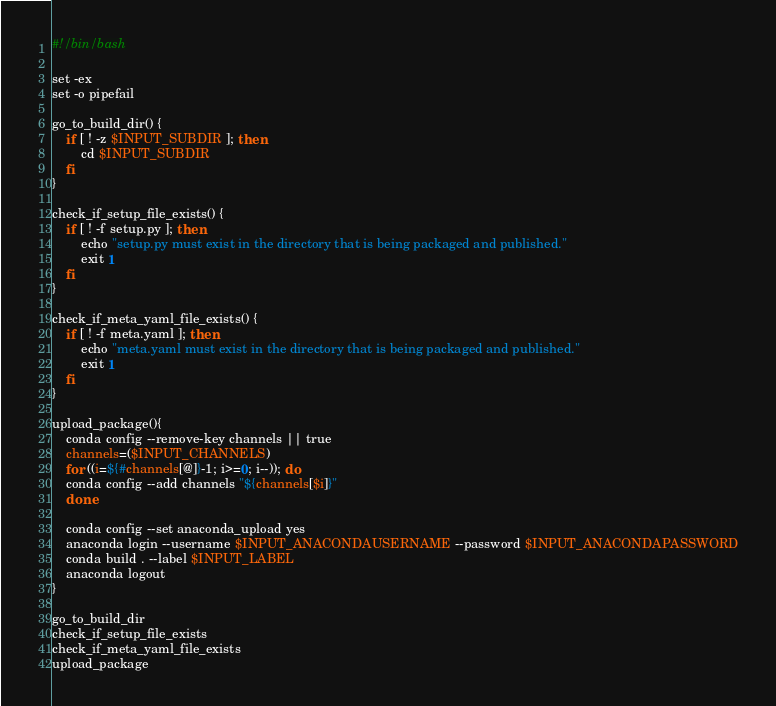Convert code to text. <code><loc_0><loc_0><loc_500><loc_500><_Bash_>#!/bin/bash

set -ex
set -o pipefail

go_to_build_dir() {
    if [ ! -z $INPUT_SUBDIR ]; then
        cd $INPUT_SUBDIR
    fi
}

check_if_setup_file_exists() {
    if [ ! -f setup.py ]; then
        echo "setup.py must exist in the directory that is being packaged and published."
        exit 1
    fi
}

check_if_meta_yaml_file_exists() {
    if [ ! -f meta.yaml ]; then
        echo "meta.yaml must exist in the directory that is being packaged and published."
        exit 1
    fi
}

upload_package(){
    conda config --remove-key channels || true
    channels=($INPUT_CHANNELS)
    for ((i=${#channels[@]}-1; i>=0; i--)); do
	conda config --add channels "${channels[$i]}"
    done

    conda config --set anaconda_upload yes
    anaconda login --username $INPUT_ANACONDAUSERNAME --password $INPUT_ANACONDAPASSWORD
    conda build . --label $INPUT_LABEL
    anaconda logout
}

go_to_build_dir
check_if_setup_file_exists
check_if_meta_yaml_file_exists
upload_package
</code> 